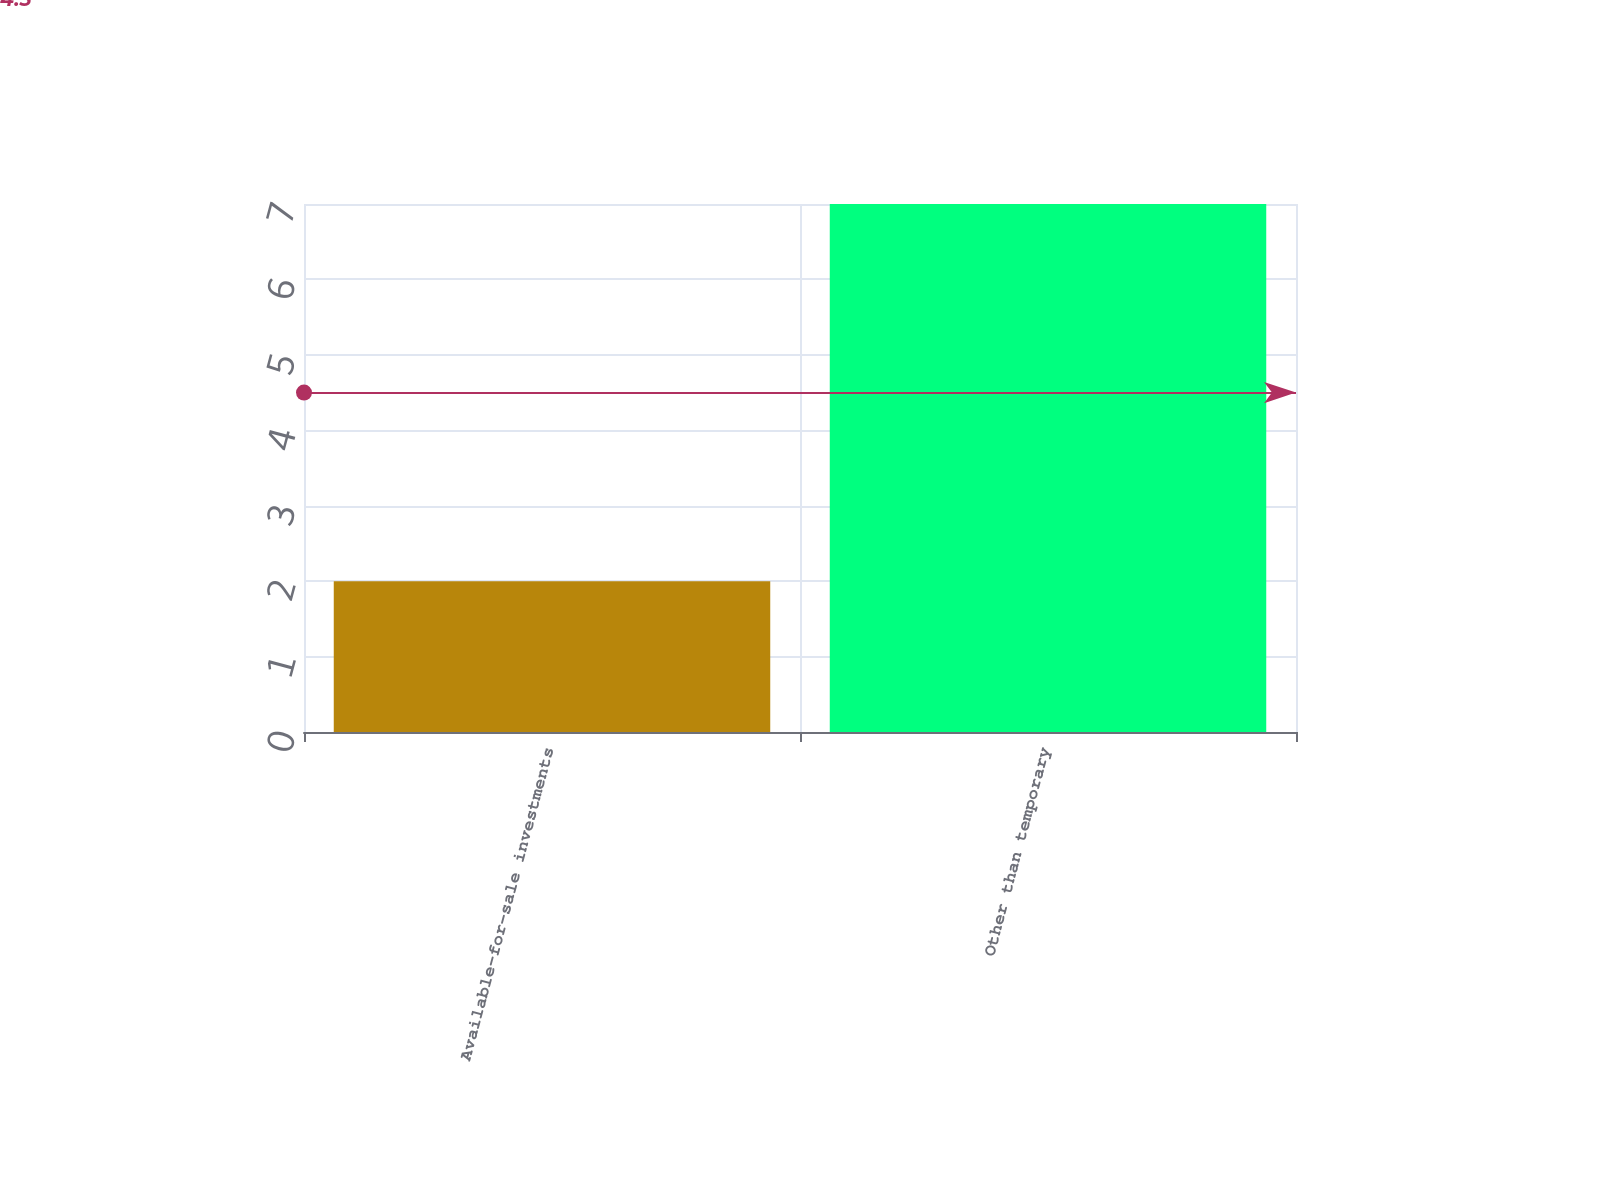Convert chart to OTSL. <chart><loc_0><loc_0><loc_500><loc_500><bar_chart><fcel>Available-for-sale investments<fcel>Other than temporary<nl><fcel>2<fcel>7<nl></chart> 